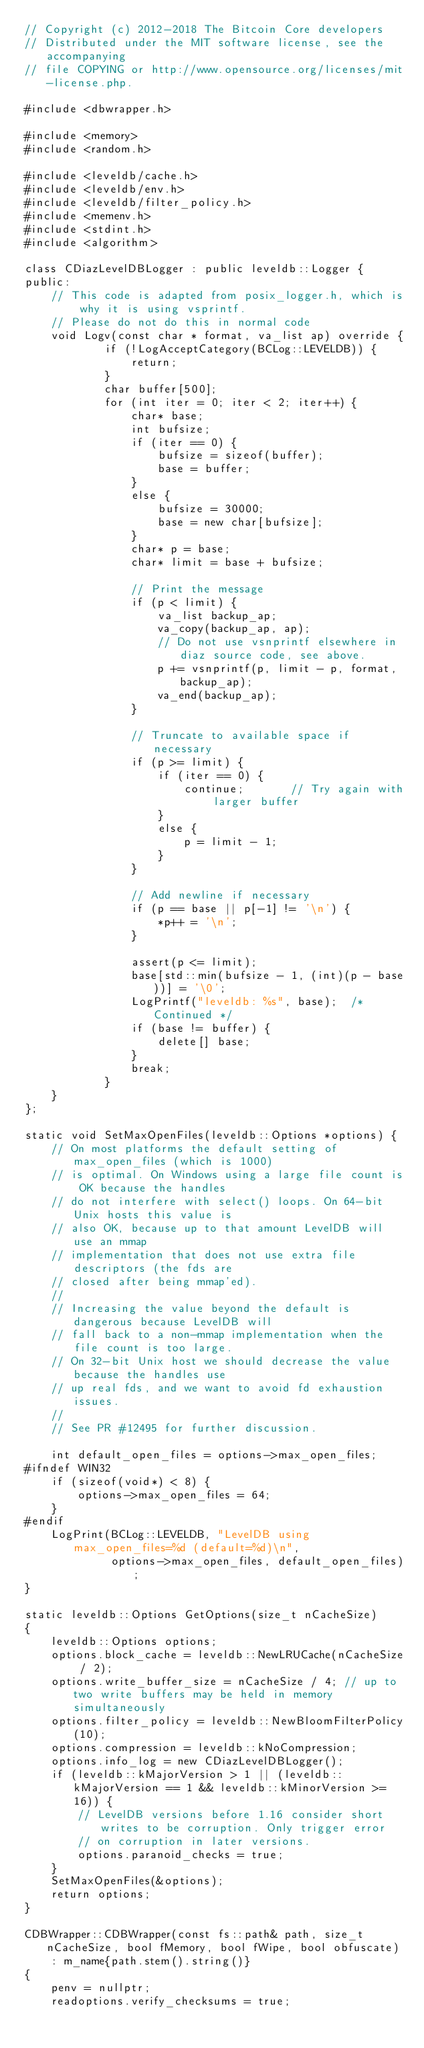<code> <loc_0><loc_0><loc_500><loc_500><_C++_>// Copyright (c) 2012-2018 The Bitcoin Core developers
// Distributed under the MIT software license, see the accompanying
// file COPYING or http://www.opensource.org/licenses/mit-license.php.

#include <dbwrapper.h>

#include <memory>
#include <random.h>

#include <leveldb/cache.h>
#include <leveldb/env.h>
#include <leveldb/filter_policy.h>
#include <memenv.h>
#include <stdint.h>
#include <algorithm>

class CDiazLevelDBLogger : public leveldb::Logger {
public:
    // This code is adapted from posix_logger.h, which is why it is using vsprintf.
    // Please do not do this in normal code
    void Logv(const char * format, va_list ap) override {
            if (!LogAcceptCategory(BCLog::LEVELDB)) {
                return;
            }
            char buffer[500];
            for (int iter = 0; iter < 2; iter++) {
                char* base;
                int bufsize;
                if (iter == 0) {
                    bufsize = sizeof(buffer);
                    base = buffer;
                }
                else {
                    bufsize = 30000;
                    base = new char[bufsize];
                }
                char* p = base;
                char* limit = base + bufsize;

                // Print the message
                if (p < limit) {
                    va_list backup_ap;
                    va_copy(backup_ap, ap);
                    // Do not use vsnprintf elsewhere in diaz source code, see above.
                    p += vsnprintf(p, limit - p, format, backup_ap);
                    va_end(backup_ap);
                }

                // Truncate to available space if necessary
                if (p >= limit) {
                    if (iter == 0) {
                        continue;       // Try again with larger buffer
                    }
                    else {
                        p = limit - 1;
                    }
                }

                // Add newline if necessary
                if (p == base || p[-1] != '\n') {
                    *p++ = '\n';
                }

                assert(p <= limit);
                base[std::min(bufsize - 1, (int)(p - base))] = '\0';
                LogPrintf("leveldb: %s", base);  /* Continued */
                if (base != buffer) {
                    delete[] base;
                }
                break;
            }
    }
};

static void SetMaxOpenFiles(leveldb::Options *options) {
    // On most platforms the default setting of max_open_files (which is 1000)
    // is optimal. On Windows using a large file count is OK because the handles
    // do not interfere with select() loops. On 64-bit Unix hosts this value is
    // also OK, because up to that amount LevelDB will use an mmap
    // implementation that does not use extra file descriptors (the fds are
    // closed after being mmap'ed).
    //
    // Increasing the value beyond the default is dangerous because LevelDB will
    // fall back to a non-mmap implementation when the file count is too large.
    // On 32-bit Unix host we should decrease the value because the handles use
    // up real fds, and we want to avoid fd exhaustion issues.
    //
    // See PR #12495 for further discussion.

    int default_open_files = options->max_open_files;
#ifndef WIN32
    if (sizeof(void*) < 8) {
        options->max_open_files = 64;
    }
#endif
    LogPrint(BCLog::LEVELDB, "LevelDB using max_open_files=%d (default=%d)\n",
             options->max_open_files, default_open_files);
}

static leveldb::Options GetOptions(size_t nCacheSize)
{
    leveldb::Options options;
    options.block_cache = leveldb::NewLRUCache(nCacheSize / 2);
    options.write_buffer_size = nCacheSize / 4; // up to two write buffers may be held in memory simultaneously
    options.filter_policy = leveldb::NewBloomFilterPolicy(10);
    options.compression = leveldb::kNoCompression;
    options.info_log = new CDiazLevelDBLogger();
    if (leveldb::kMajorVersion > 1 || (leveldb::kMajorVersion == 1 && leveldb::kMinorVersion >= 16)) {
        // LevelDB versions before 1.16 consider short writes to be corruption. Only trigger error
        // on corruption in later versions.
        options.paranoid_checks = true;
    }
    SetMaxOpenFiles(&options);
    return options;
}

CDBWrapper::CDBWrapper(const fs::path& path, size_t nCacheSize, bool fMemory, bool fWipe, bool obfuscate)
    : m_name{path.stem().string()}
{
    penv = nullptr;
    readoptions.verify_checksums = true;</code> 